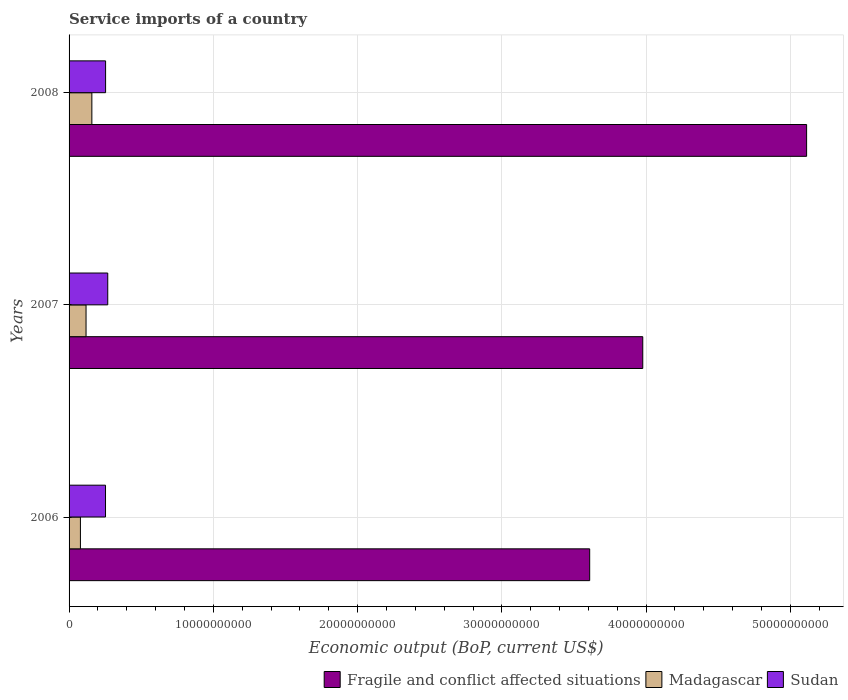How many different coloured bars are there?
Offer a very short reply. 3. How many groups of bars are there?
Provide a short and direct response. 3. Are the number of bars per tick equal to the number of legend labels?
Your response must be concise. Yes. Are the number of bars on each tick of the Y-axis equal?
Your response must be concise. Yes. How many bars are there on the 1st tick from the bottom?
Offer a terse response. 3. What is the label of the 1st group of bars from the top?
Offer a very short reply. 2008. In how many cases, is the number of bars for a given year not equal to the number of legend labels?
Your answer should be very brief. 0. What is the service imports in Fragile and conflict affected situations in 2007?
Offer a terse response. 3.98e+1. Across all years, what is the maximum service imports in Fragile and conflict affected situations?
Offer a terse response. 5.11e+1. Across all years, what is the minimum service imports in Madagascar?
Offer a terse response. 7.87e+08. In which year was the service imports in Fragile and conflict affected situations maximum?
Offer a very short reply. 2008. What is the total service imports in Madagascar in the graph?
Provide a succinct answer. 3.54e+09. What is the difference between the service imports in Fragile and conflict affected situations in 2007 and that in 2008?
Offer a terse response. -1.14e+1. What is the difference between the service imports in Madagascar in 2008 and the service imports in Fragile and conflict affected situations in 2007?
Offer a very short reply. -3.82e+1. What is the average service imports in Sudan per year?
Provide a short and direct response. 2.58e+09. In the year 2007, what is the difference between the service imports in Fragile and conflict affected situations and service imports in Madagascar?
Your answer should be compact. 3.86e+1. What is the ratio of the service imports in Madagascar in 2007 to that in 2008?
Offer a terse response. 0.74. Is the service imports in Sudan in 2006 less than that in 2008?
Provide a short and direct response. Yes. What is the difference between the highest and the second highest service imports in Fragile and conflict affected situations?
Provide a succinct answer. 1.14e+1. What is the difference between the highest and the lowest service imports in Sudan?
Keep it short and to the point. 1.55e+08. In how many years, is the service imports in Fragile and conflict affected situations greater than the average service imports in Fragile and conflict affected situations taken over all years?
Provide a succinct answer. 1. What does the 3rd bar from the top in 2006 represents?
Your answer should be very brief. Fragile and conflict affected situations. What does the 3rd bar from the bottom in 2006 represents?
Offer a very short reply. Sudan. Is it the case that in every year, the sum of the service imports in Fragile and conflict affected situations and service imports in Madagascar is greater than the service imports in Sudan?
Give a very brief answer. Yes. How many bars are there?
Keep it short and to the point. 9. Are all the bars in the graph horizontal?
Offer a terse response. Yes. How many years are there in the graph?
Make the answer very short. 3. Does the graph contain grids?
Offer a terse response. Yes. How are the legend labels stacked?
Provide a short and direct response. Horizontal. What is the title of the graph?
Your answer should be compact. Service imports of a country. Does "Malta" appear as one of the legend labels in the graph?
Provide a short and direct response. No. What is the label or title of the X-axis?
Provide a succinct answer. Economic output (BoP, current US$). What is the Economic output (BoP, current US$) of Fragile and conflict affected situations in 2006?
Provide a short and direct response. 3.61e+1. What is the Economic output (BoP, current US$) of Madagascar in 2006?
Your response must be concise. 7.87e+08. What is the Economic output (BoP, current US$) in Sudan in 2006?
Your response must be concise. 2.53e+09. What is the Economic output (BoP, current US$) in Fragile and conflict affected situations in 2007?
Ensure brevity in your answer.  3.98e+1. What is the Economic output (BoP, current US$) of Madagascar in 2007?
Provide a succinct answer. 1.18e+09. What is the Economic output (BoP, current US$) of Sudan in 2007?
Make the answer very short. 2.68e+09. What is the Economic output (BoP, current US$) in Fragile and conflict affected situations in 2008?
Offer a terse response. 5.11e+1. What is the Economic output (BoP, current US$) of Madagascar in 2008?
Make the answer very short. 1.58e+09. What is the Economic output (BoP, current US$) of Sudan in 2008?
Ensure brevity in your answer.  2.53e+09. Across all years, what is the maximum Economic output (BoP, current US$) in Fragile and conflict affected situations?
Your answer should be very brief. 5.11e+1. Across all years, what is the maximum Economic output (BoP, current US$) in Madagascar?
Ensure brevity in your answer.  1.58e+09. Across all years, what is the maximum Economic output (BoP, current US$) of Sudan?
Your response must be concise. 2.68e+09. Across all years, what is the minimum Economic output (BoP, current US$) in Fragile and conflict affected situations?
Keep it short and to the point. 3.61e+1. Across all years, what is the minimum Economic output (BoP, current US$) of Madagascar?
Your response must be concise. 7.87e+08. Across all years, what is the minimum Economic output (BoP, current US$) in Sudan?
Provide a short and direct response. 2.53e+09. What is the total Economic output (BoP, current US$) of Fragile and conflict affected situations in the graph?
Give a very brief answer. 1.27e+11. What is the total Economic output (BoP, current US$) of Madagascar in the graph?
Make the answer very short. 3.54e+09. What is the total Economic output (BoP, current US$) of Sudan in the graph?
Make the answer very short. 7.74e+09. What is the difference between the Economic output (BoP, current US$) of Fragile and conflict affected situations in 2006 and that in 2007?
Your response must be concise. -3.68e+09. What is the difference between the Economic output (BoP, current US$) of Madagascar in 2006 and that in 2007?
Make the answer very short. -3.90e+08. What is the difference between the Economic output (BoP, current US$) in Sudan in 2006 and that in 2007?
Give a very brief answer. -1.55e+08. What is the difference between the Economic output (BoP, current US$) of Fragile and conflict affected situations in 2006 and that in 2008?
Provide a short and direct response. -1.50e+1. What is the difference between the Economic output (BoP, current US$) in Madagascar in 2006 and that in 2008?
Make the answer very short. -7.93e+08. What is the difference between the Economic output (BoP, current US$) in Sudan in 2006 and that in 2008?
Your response must be concise. -6.05e+06. What is the difference between the Economic output (BoP, current US$) of Fragile and conflict affected situations in 2007 and that in 2008?
Your response must be concise. -1.14e+1. What is the difference between the Economic output (BoP, current US$) in Madagascar in 2007 and that in 2008?
Offer a terse response. -4.03e+08. What is the difference between the Economic output (BoP, current US$) of Sudan in 2007 and that in 2008?
Make the answer very short. 1.49e+08. What is the difference between the Economic output (BoP, current US$) in Fragile and conflict affected situations in 2006 and the Economic output (BoP, current US$) in Madagascar in 2007?
Provide a short and direct response. 3.49e+1. What is the difference between the Economic output (BoP, current US$) in Fragile and conflict affected situations in 2006 and the Economic output (BoP, current US$) in Sudan in 2007?
Your answer should be very brief. 3.34e+1. What is the difference between the Economic output (BoP, current US$) of Madagascar in 2006 and the Economic output (BoP, current US$) of Sudan in 2007?
Your answer should be very brief. -1.89e+09. What is the difference between the Economic output (BoP, current US$) of Fragile and conflict affected situations in 2006 and the Economic output (BoP, current US$) of Madagascar in 2008?
Your answer should be very brief. 3.45e+1. What is the difference between the Economic output (BoP, current US$) of Fragile and conflict affected situations in 2006 and the Economic output (BoP, current US$) of Sudan in 2008?
Your answer should be compact. 3.36e+1. What is the difference between the Economic output (BoP, current US$) in Madagascar in 2006 and the Economic output (BoP, current US$) in Sudan in 2008?
Provide a succinct answer. -1.75e+09. What is the difference between the Economic output (BoP, current US$) of Fragile and conflict affected situations in 2007 and the Economic output (BoP, current US$) of Madagascar in 2008?
Offer a very short reply. 3.82e+1. What is the difference between the Economic output (BoP, current US$) of Fragile and conflict affected situations in 2007 and the Economic output (BoP, current US$) of Sudan in 2008?
Provide a succinct answer. 3.72e+1. What is the difference between the Economic output (BoP, current US$) in Madagascar in 2007 and the Economic output (BoP, current US$) in Sudan in 2008?
Make the answer very short. -1.36e+09. What is the average Economic output (BoP, current US$) in Fragile and conflict affected situations per year?
Provide a short and direct response. 4.23e+1. What is the average Economic output (BoP, current US$) in Madagascar per year?
Provide a short and direct response. 1.18e+09. What is the average Economic output (BoP, current US$) of Sudan per year?
Provide a succinct answer. 2.58e+09. In the year 2006, what is the difference between the Economic output (BoP, current US$) of Fragile and conflict affected situations and Economic output (BoP, current US$) of Madagascar?
Provide a short and direct response. 3.53e+1. In the year 2006, what is the difference between the Economic output (BoP, current US$) in Fragile and conflict affected situations and Economic output (BoP, current US$) in Sudan?
Offer a very short reply. 3.36e+1. In the year 2006, what is the difference between the Economic output (BoP, current US$) of Madagascar and Economic output (BoP, current US$) of Sudan?
Keep it short and to the point. -1.74e+09. In the year 2007, what is the difference between the Economic output (BoP, current US$) of Fragile and conflict affected situations and Economic output (BoP, current US$) of Madagascar?
Give a very brief answer. 3.86e+1. In the year 2007, what is the difference between the Economic output (BoP, current US$) of Fragile and conflict affected situations and Economic output (BoP, current US$) of Sudan?
Ensure brevity in your answer.  3.71e+1. In the year 2007, what is the difference between the Economic output (BoP, current US$) of Madagascar and Economic output (BoP, current US$) of Sudan?
Your answer should be compact. -1.50e+09. In the year 2008, what is the difference between the Economic output (BoP, current US$) of Fragile and conflict affected situations and Economic output (BoP, current US$) of Madagascar?
Make the answer very short. 4.95e+1. In the year 2008, what is the difference between the Economic output (BoP, current US$) in Fragile and conflict affected situations and Economic output (BoP, current US$) in Sudan?
Give a very brief answer. 4.86e+1. In the year 2008, what is the difference between the Economic output (BoP, current US$) of Madagascar and Economic output (BoP, current US$) of Sudan?
Keep it short and to the point. -9.52e+08. What is the ratio of the Economic output (BoP, current US$) in Fragile and conflict affected situations in 2006 to that in 2007?
Your answer should be very brief. 0.91. What is the ratio of the Economic output (BoP, current US$) in Madagascar in 2006 to that in 2007?
Your answer should be very brief. 0.67. What is the ratio of the Economic output (BoP, current US$) in Sudan in 2006 to that in 2007?
Ensure brevity in your answer.  0.94. What is the ratio of the Economic output (BoP, current US$) in Fragile and conflict affected situations in 2006 to that in 2008?
Offer a terse response. 0.71. What is the ratio of the Economic output (BoP, current US$) in Madagascar in 2006 to that in 2008?
Offer a very short reply. 0.5. What is the ratio of the Economic output (BoP, current US$) in Madagascar in 2007 to that in 2008?
Keep it short and to the point. 0.74. What is the ratio of the Economic output (BoP, current US$) in Sudan in 2007 to that in 2008?
Make the answer very short. 1.06. What is the difference between the highest and the second highest Economic output (BoP, current US$) of Fragile and conflict affected situations?
Offer a terse response. 1.14e+1. What is the difference between the highest and the second highest Economic output (BoP, current US$) of Madagascar?
Make the answer very short. 4.03e+08. What is the difference between the highest and the second highest Economic output (BoP, current US$) of Sudan?
Give a very brief answer. 1.49e+08. What is the difference between the highest and the lowest Economic output (BoP, current US$) in Fragile and conflict affected situations?
Ensure brevity in your answer.  1.50e+1. What is the difference between the highest and the lowest Economic output (BoP, current US$) in Madagascar?
Provide a succinct answer. 7.93e+08. What is the difference between the highest and the lowest Economic output (BoP, current US$) in Sudan?
Provide a short and direct response. 1.55e+08. 